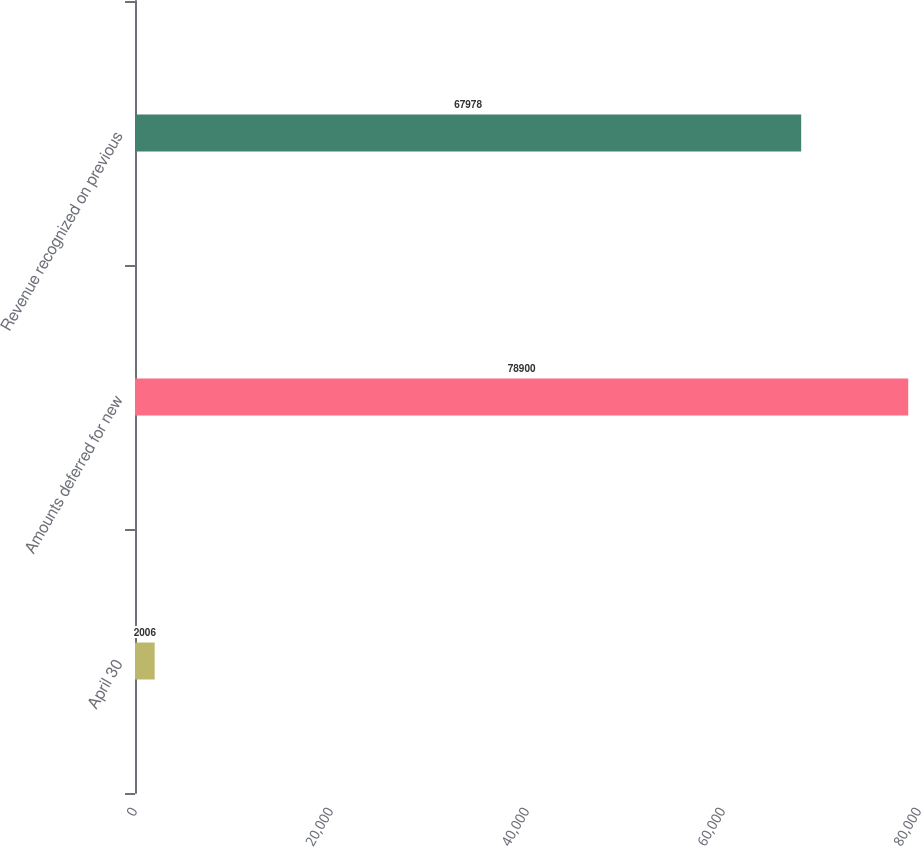Convert chart. <chart><loc_0><loc_0><loc_500><loc_500><bar_chart><fcel>April 30<fcel>Amounts deferred for new<fcel>Revenue recognized on previous<nl><fcel>2006<fcel>78900<fcel>67978<nl></chart> 